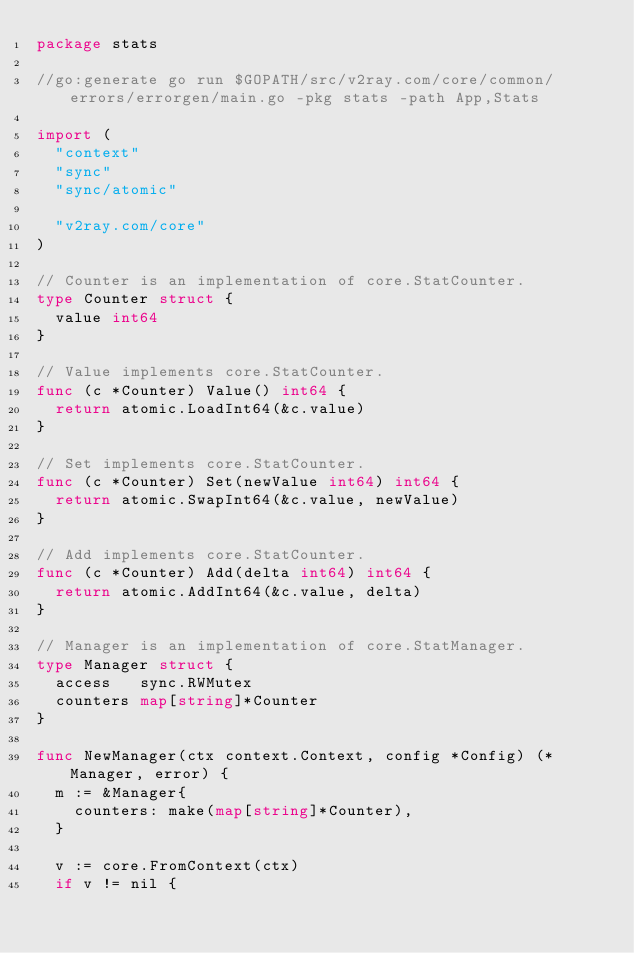Convert code to text. <code><loc_0><loc_0><loc_500><loc_500><_Go_>package stats

//go:generate go run $GOPATH/src/v2ray.com/core/common/errors/errorgen/main.go -pkg stats -path App,Stats

import (
	"context"
	"sync"
	"sync/atomic"

	"v2ray.com/core"
)

// Counter is an implementation of core.StatCounter.
type Counter struct {
	value int64
}

// Value implements core.StatCounter.
func (c *Counter) Value() int64 {
	return atomic.LoadInt64(&c.value)
}

// Set implements core.StatCounter.
func (c *Counter) Set(newValue int64) int64 {
	return atomic.SwapInt64(&c.value, newValue)
}

// Add implements core.StatCounter.
func (c *Counter) Add(delta int64) int64 {
	return atomic.AddInt64(&c.value, delta)
}

// Manager is an implementation of core.StatManager.
type Manager struct {
	access   sync.RWMutex
	counters map[string]*Counter
}

func NewManager(ctx context.Context, config *Config) (*Manager, error) {
	m := &Manager{
		counters: make(map[string]*Counter),
	}

	v := core.FromContext(ctx)
	if v != nil {</code> 